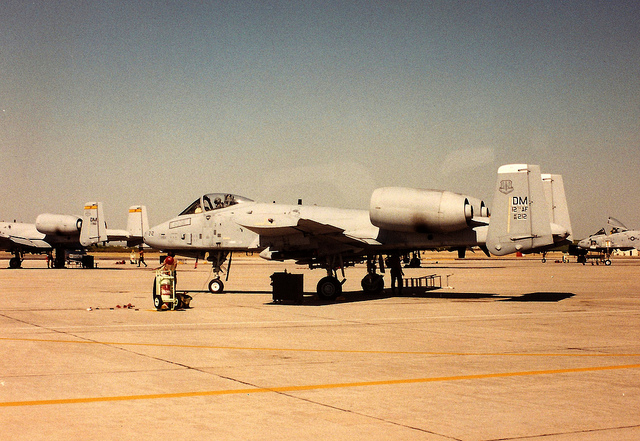<image>How many people does this plane carry? It's uncertain as to how many people this plane carries. The number could be 1, 2, 4, or 6. How many people does this plane carry? It is unclear how many people this plane carries. It can be either 1, 2, 4, or 6. 